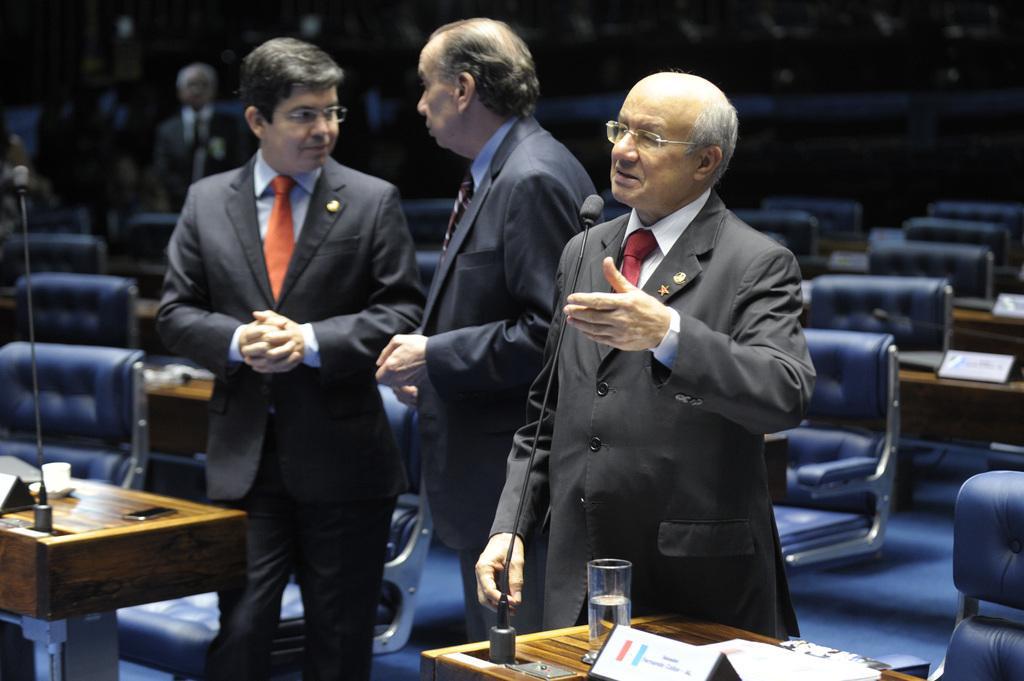How would you summarize this image in a sentence or two? In this image I see 3 men who are standing and this man is in front of a mic, I can also see there are lot of chairs and tables on which there are few things on it. In the background I see few people. 